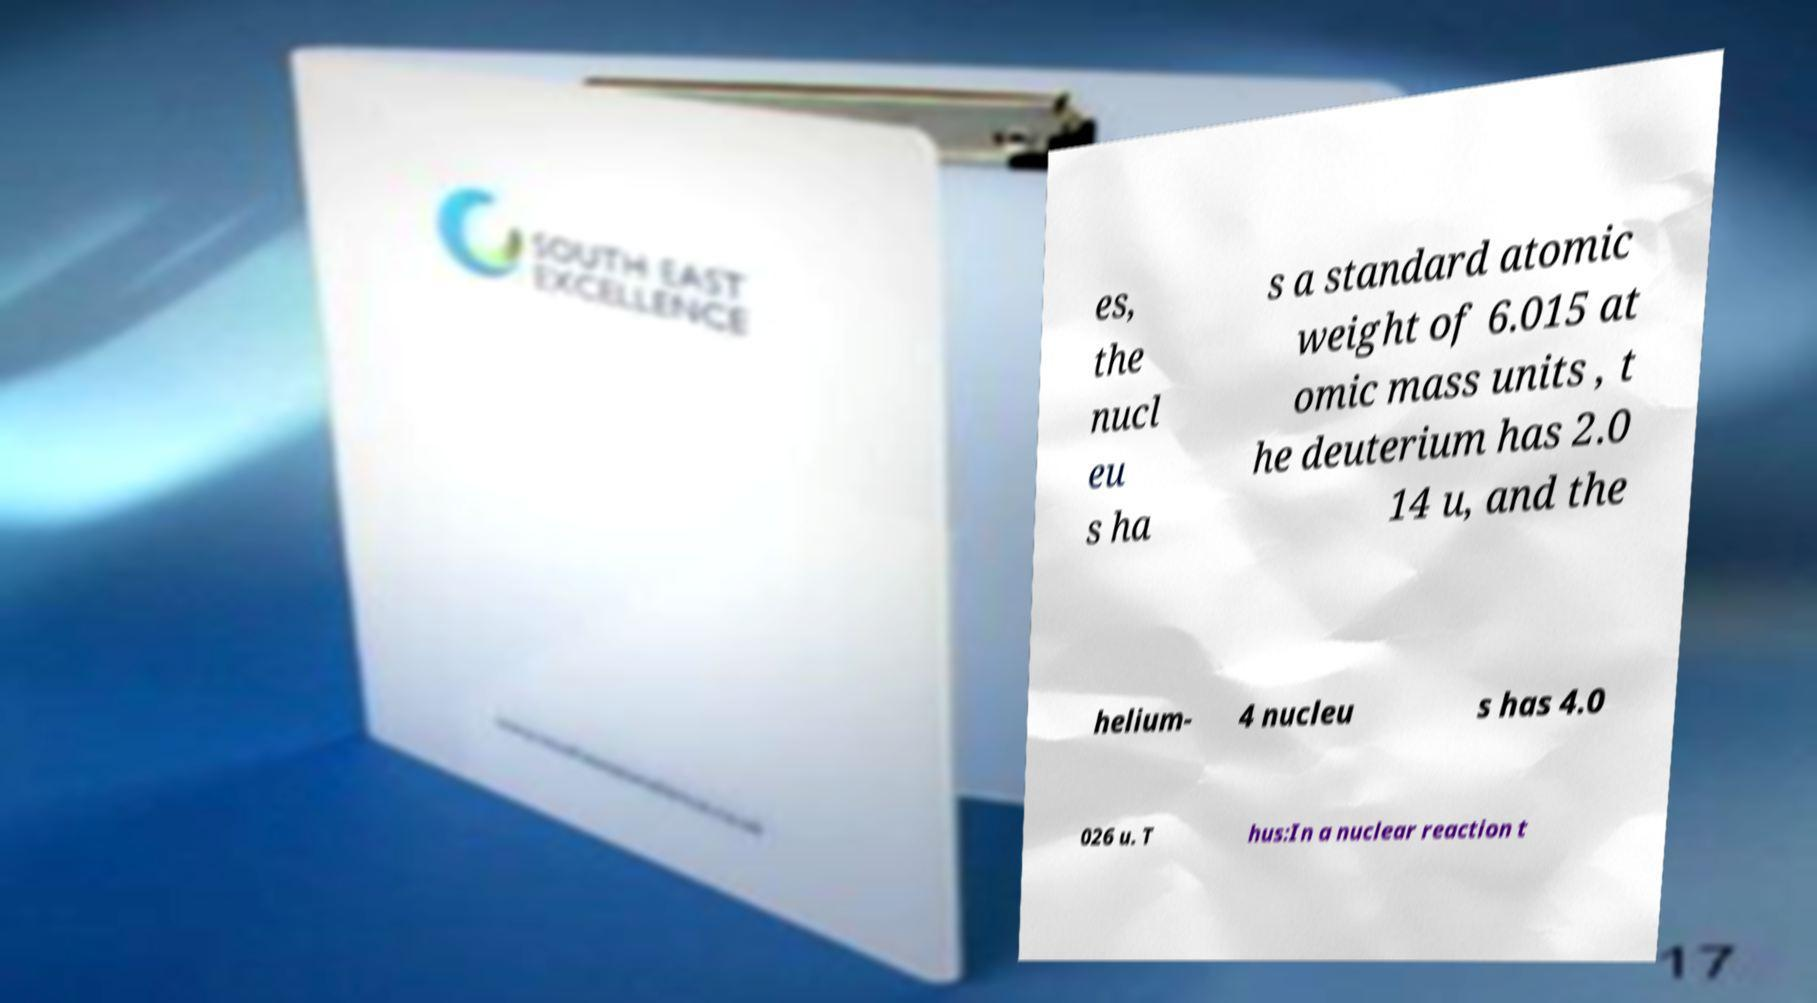For documentation purposes, I need the text within this image transcribed. Could you provide that? es, the nucl eu s ha s a standard atomic weight of 6.015 at omic mass units , t he deuterium has 2.0 14 u, and the helium- 4 nucleu s has 4.0 026 u. T hus:In a nuclear reaction t 